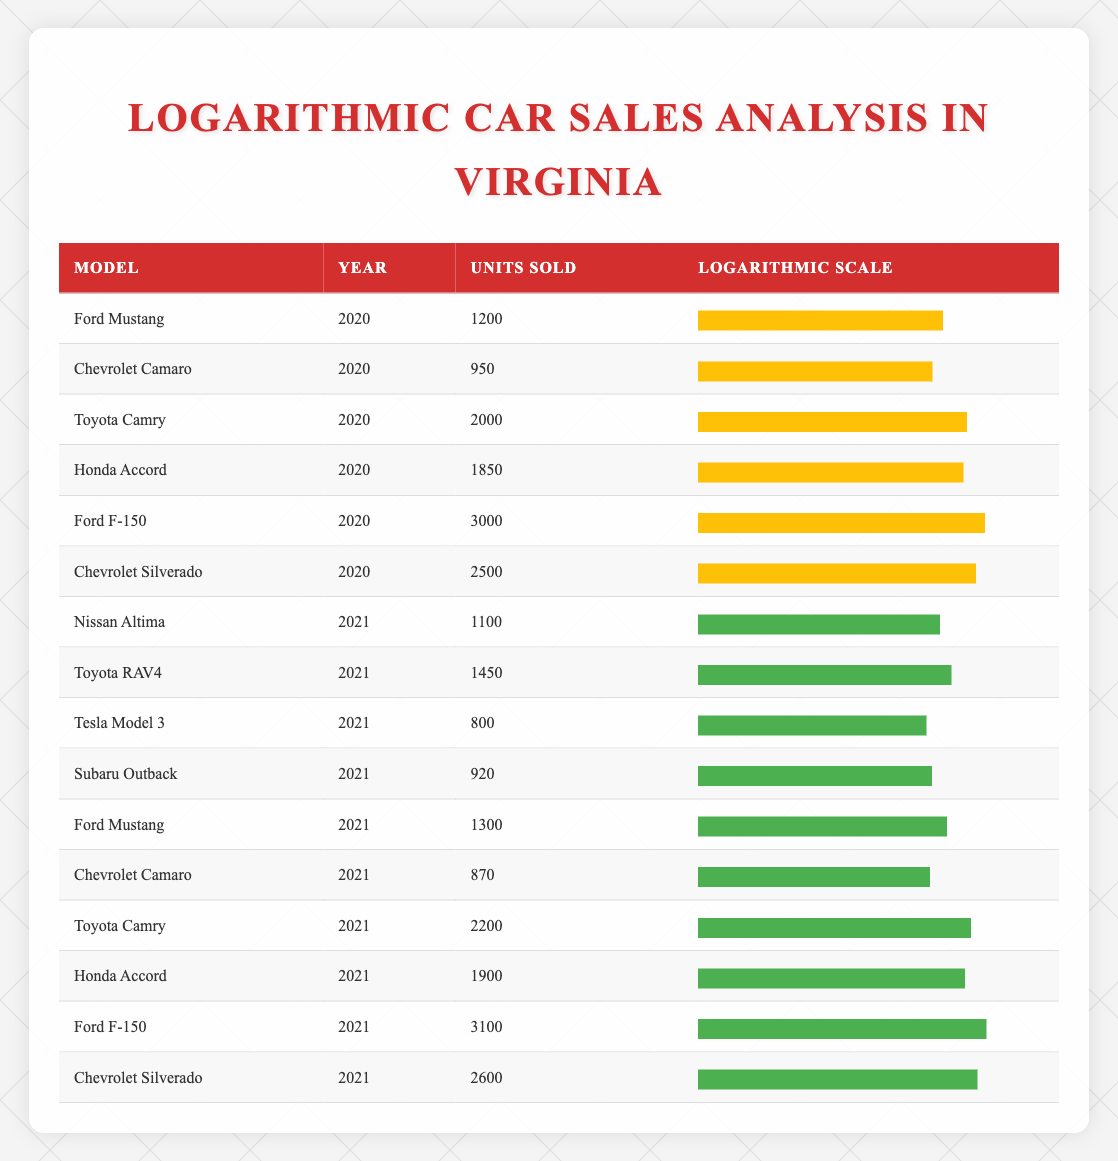What is the total number of units sold for the Ford F-150 across both years? The units sold for Ford F-150 in 2020 is 3000. In 2021, it is 3100. To find the total, we sum these two values: 3000 + 3100 = 6100.
Answer: 6100 Which model had the highest units sold in 2021? According to the data, the Ford F-150 had 3100 units sold in 2021, which is higher than any other model for that year.
Answer: Ford F-150 How many units did the Toyota Camry sell in 2020? The table shows that in 2020, the Toyota Camry had 2000 units sold.
Answer: 2000 Is the Chevrolet Silverado's sales in 2021 greater than its sales in 2020? In 2021, the Chevrolet Silverado sold 2600 units, while in 2020 it sold 2500 units. 2600 is greater than 2500, confirming the statement is true.
Answer: Yes What is the average number of units sold for the Ford Mustang over the two years? The Ford Mustang sold 1200 units in 2020 and 1300 units in 2021. To find the average, we add 1200 + 1300 = 2500 and then divide by 2, which gives 2500 / 2 = 1250.
Answer: 1250 What was the difference in units sold between the Honda Accord in 2020 and 2021? The Honda Accord sold 1850 units in 2020 and 1900 in 2021. To find the difference, we subtract 1850 from 1900: 1900 - 1850 = 50.
Answer: 50 List all models that sold more than 2000 units in 2021. The only model that sold more than 2000 units in 2021 is the Ford F-150 with 3100 units sold and the Chevrolet Silverado with 2600 units sold.
Answer: Ford F-150, Chevrolet Silverado Was the sales performance of the rival models, Ford Mustang and Chevrolet Camaro, better in 2021 than in 2020? In 2020, the Ford Mustang sold 1200 units and the Chevrolet Camaro sold 950 units. In 2021, the Ford Mustang sold 1300 units and the Chevrolet Camaro sold 870 units. For the Ford Mustang, 1300 is more than 1200, but for the Chevrolet Camaro, 870 is less than 950. Thus, the performance was not better for both models.
Answer: No Which model had a higher logarithmic scale representation for units sold in 2020, Ford F-150 or Chevrolet Silverado? The Ford F-150 sold 3000 units in 2020 and had its logarithmic scale representation show a bar width of 82.9%. The Chevrolet Silverado sold 2500 units, corresponding to a bar width of 80.4%. Since 82.9% is greater than 80.4%, Ford F-150 had a higher logarithmic scale representation.
Answer: Ford F-150 